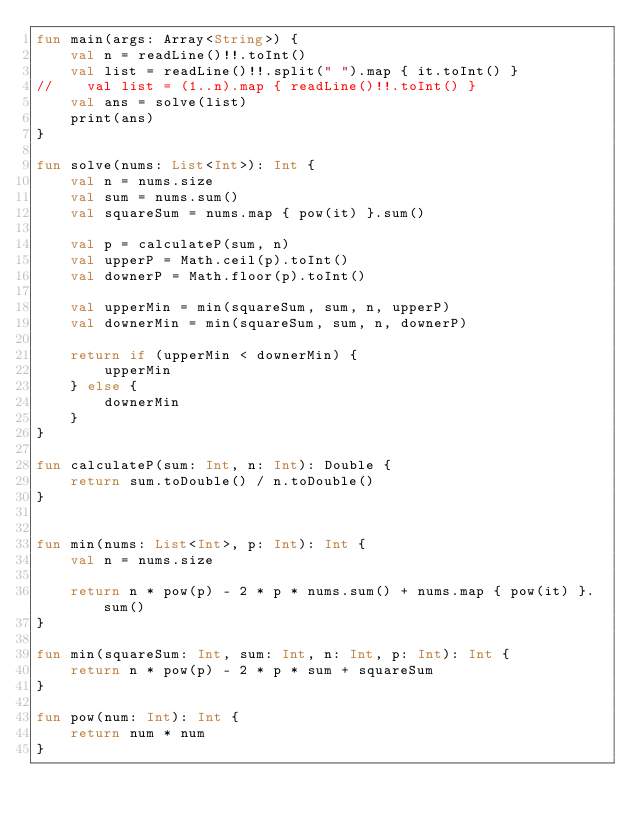<code> <loc_0><loc_0><loc_500><loc_500><_Kotlin_>fun main(args: Array<String>) {
    val n = readLine()!!.toInt()
    val list = readLine()!!.split(" ").map { it.toInt() }
//    val list = (1..n).map { readLine()!!.toInt() }
    val ans = solve(list)
    print(ans)
}

fun solve(nums: List<Int>): Int {
    val n = nums.size
    val sum = nums.sum()
    val squareSum = nums.map { pow(it) }.sum()

    val p = calculateP(sum, n)
    val upperP = Math.ceil(p).toInt()
    val downerP = Math.floor(p).toInt()

    val upperMin = min(squareSum, sum, n, upperP)
    val downerMin = min(squareSum, sum, n, downerP)

    return if (upperMin < downerMin) {
        upperMin
    } else {
        downerMin
    }
}

fun calculateP(sum: Int, n: Int): Double {
    return sum.toDouble() / n.toDouble()
}


fun min(nums: List<Int>, p: Int): Int {
    val n = nums.size

    return n * pow(p) - 2 * p * nums.sum() + nums.map { pow(it) }.sum()
}

fun min(squareSum: Int, sum: Int, n: Int, p: Int): Int {
    return n * pow(p) - 2 * p * sum + squareSum
}

fun pow(num: Int): Int {
    return num * num
}

</code> 